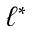<formula> <loc_0><loc_0><loc_500><loc_500>\ell ^ { * }</formula> 